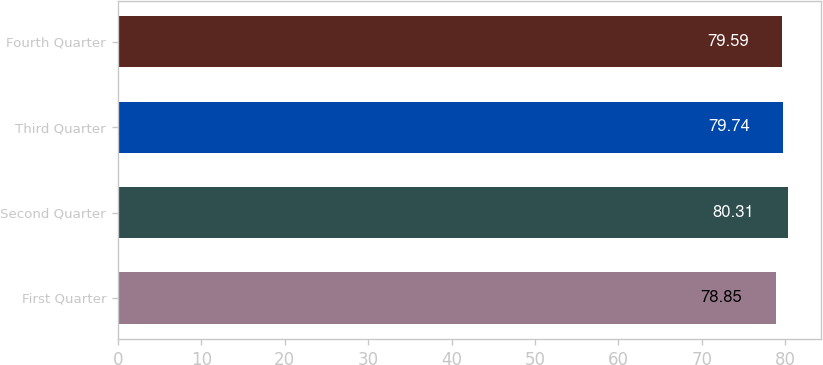<chart> <loc_0><loc_0><loc_500><loc_500><bar_chart><fcel>First Quarter<fcel>Second Quarter<fcel>Third Quarter<fcel>Fourth Quarter<nl><fcel>78.85<fcel>80.31<fcel>79.74<fcel>79.59<nl></chart> 